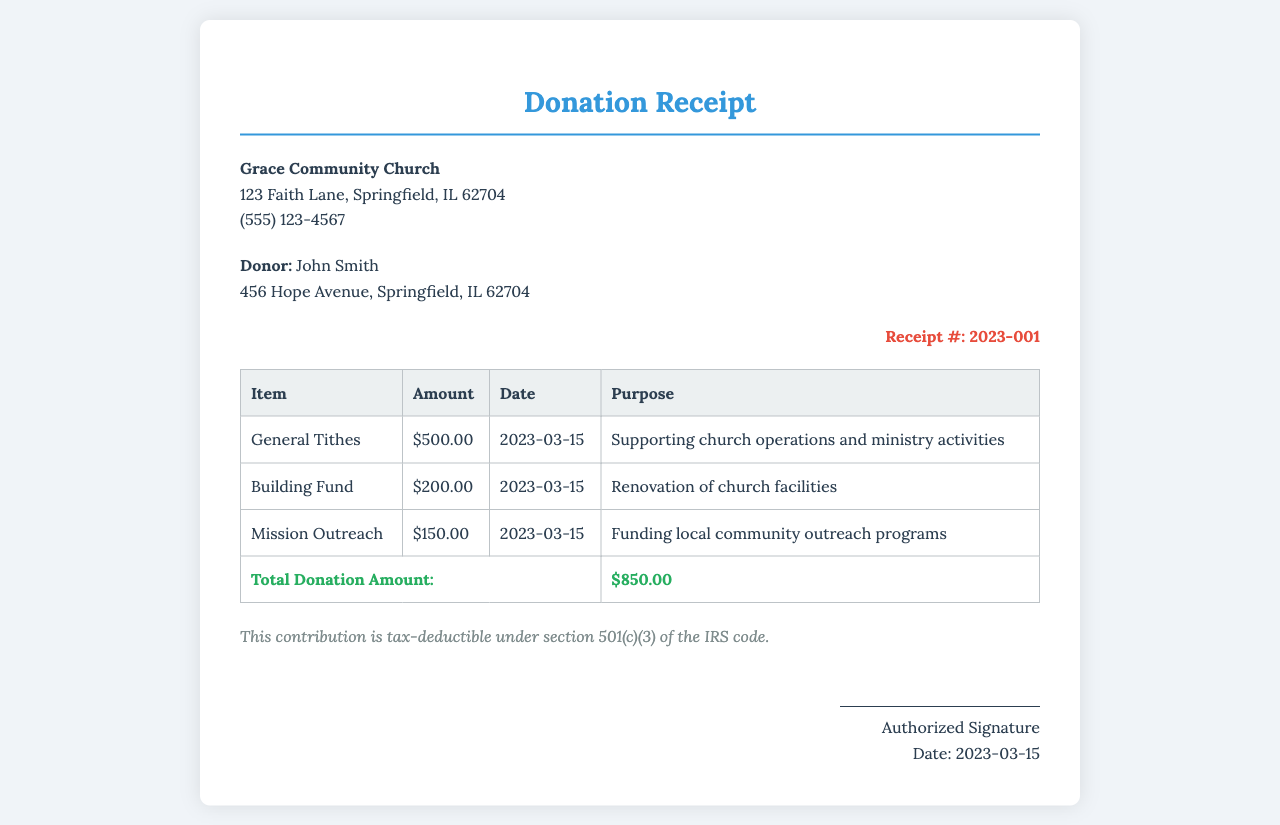what is the name of the church? The name of the church is stated clearly at the top of the document.
Answer: Grace Community Church what is the total donation amount? The total donation amount is calculated and shown at the bottom of the donation table.
Answer: $850.00 who is the donor? The donor's name is listed in the donor information section of the document.
Answer: John Smith what is the date of the donation? The date of the donation is mentioned in the signature section at the bottom of the document.
Answer: 2023-03-15 how much was contributed to the Building Fund? The Building Fund donation amount is listed in the donation table.
Answer: $200.00 which section of the IRS code makes this contribution tax-deductible? The section of the IRS code is specified in the tax information below the donation table.
Answer: 501(c)(3) what is the purpose of the Mission Outreach donation? The purpose of the Mission Outreach donation is described next to its amount in the donation table.
Answer: Funding local community outreach programs what is the receipt number? The receipt number is indicated at the top right of the document.
Answer: 2023-001 how many itemized donations are listed? The number of itemized donations can be counted from the rows in the donation table.
Answer: 3 